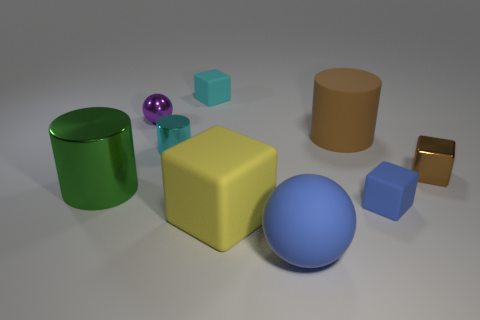Can you tell me which objects in the image are reflective? In the image, several objects exhibit reflective properties. The small cyan metallic cylinder and the little gold cube on the right have a high sheen, indicating a metallic surface that is highly reflective. Additionally, the purple sphere also has a noticeable shine. 